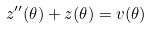<formula> <loc_0><loc_0><loc_500><loc_500>z ^ { \prime \prime } ( \theta ) + z ( \theta ) = v ( \theta )</formula> 